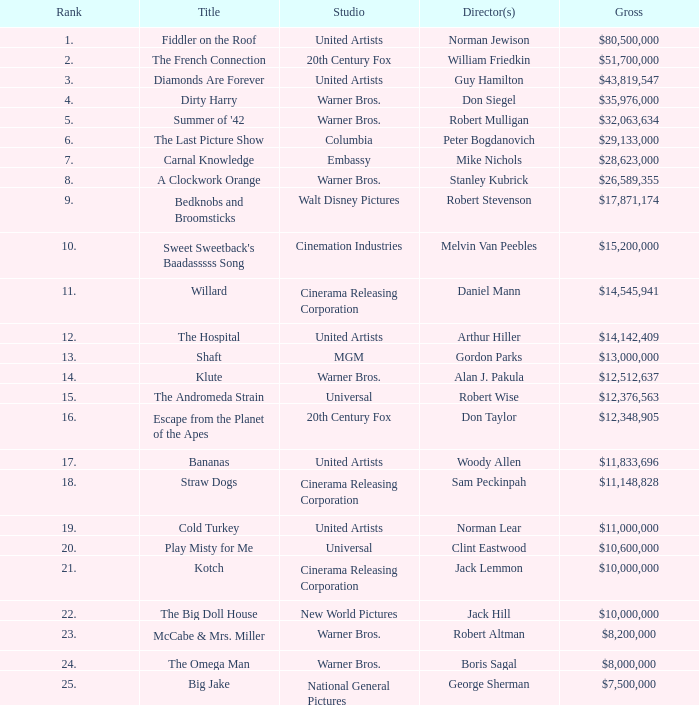With a gross of $26,589,355, what is the ranking of the title? 8.0. Could you parse the entire table as a dict? {'header': ['Rank', 'Title', 'Studio', 'Director(s)', 'Gross'], 'rows': [['1.', 'Fiddler on the Roof', 'United Artists', 'Norman Jewison', '$80,500,000'], ['2.', 'The French Connection', '20th Century Fox', 'William Friedkin', '$51,700,000'], ['3.', 'Diamonds Are Forever', 'United Artists', 'Guy Hamilton', '$43,819,547'], ['4.', 'Dirty Harry', 'Warner Bros.', 'Don Siegel', '$35,976,000'], ['5.', "Summer of '42", 'Warner Bros.', 'Robert Mulligan', '$32,063,634'], ['6.', 'The Last Picture Show', 'Columbia', 'Peter Bogdanovich', '$29,133,000'], ['7.', 'Carnal Knowledge', 'Embassy', 'Mike Nichols', '$28,623,000'], ['8.', 'A Clockwork Orange', 'Warner Bros.', 'Stanley Kubrick', '$26,589,355'], ['9.', 'Bedknobs and Broomsticks', 'Walt Disney Pictures', 'Robert Stevenson', '$17,871,174'], ['10.', "Sweet Sweetback's Baadasssss Song", 'Cinemation Industries', 'Melvin Van Peebles', '$15,200,000'], ['11.', 'Willard', 'Cinerama Releasing Corporation', 'Daniel Mann', '$14,545,941'], ['12.', 'The Hospital', 'United Artists', 'Arthur Hiller', '$14,142,409'], ['13.', 'Shaft', 'MGM', 'Gordon Parks', '$13,000,000'], ['14.', 'Klute', 'Warner Bros.', 'Alan J. Pakula', '$12,512,637'], ['15.', 'The Andromeda Strain', 'Universal', 'Robert Wise', '$12,376,563'], ['16.', 'Escape from the Planet of the Apes', '20th Century Fox', 'Don Taylor', '$12,348,905'], ['17.', 'Bananas', 'United Artists', 'Woody Allen', '$11,833,696'], ['18.', 'Straw Dogs', 'Cinerama Releasing Corporation', 'Sam Peckinpah', '$11,148,828'], ['19.', 'Cold Turkey', 'United Artists', 'Norman Lear', '$11,000,000'], ['20.', 'Play Misty for Me', 'Universal', 'Clint Eastwood', '$10,600,000'], ['21.', 'Kotch', 'Cinerama Releasing Corporation', 'Jack Lemmon', '$10,000,000'], ['22.', 'The Big Doll House', 'New World Pictures', 'Jack Hill', '$10,000,000'], ['23.', 'McCabe & Mrs. Miller', 'Warner Bros.', 'Robert Altman', '$8,200,000'], ['24.', 'The Omega Man', 'Warner Bros.', 'Boris Sagal', '$8,000,000'], ['25.', 'Big Jake', 'National General Pictures', 'George Sherman', '$7,500,000']]} 